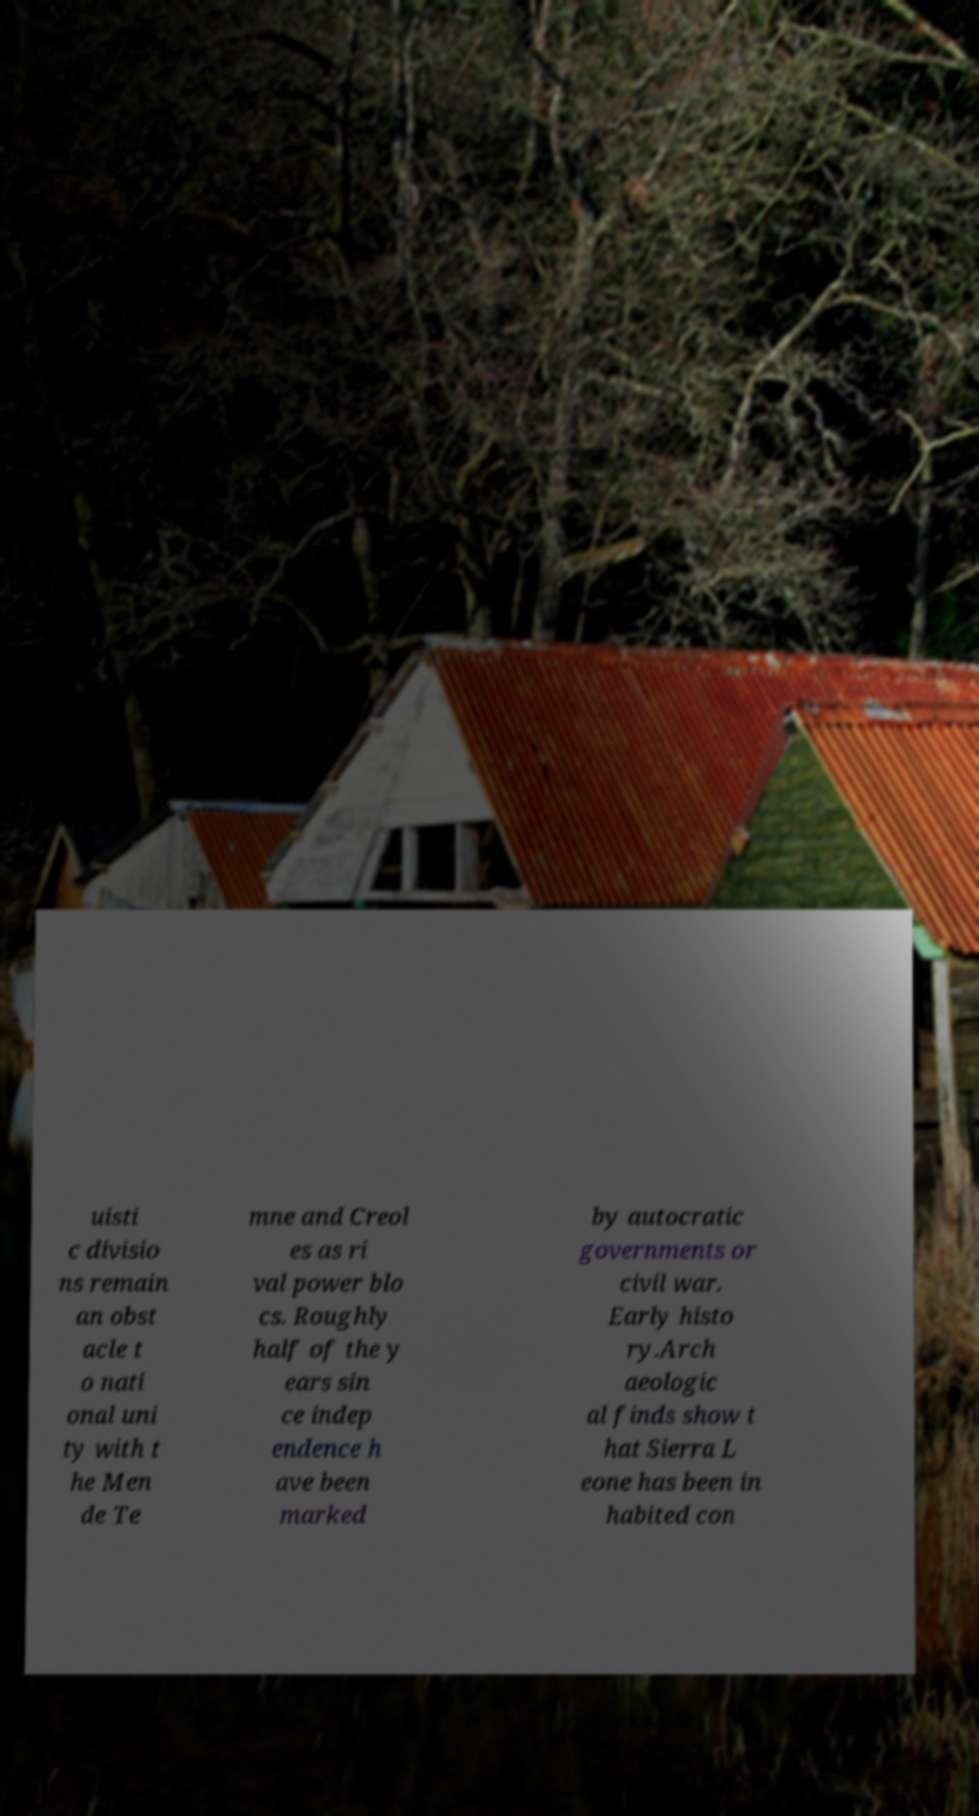For documentation purposes, I need the text within this image transcribed. Could you provide that? uisti c divisio ns remain an obst acle t o nati onal uni ty with t he Men de Te mne and Creol es as ri val power blo cs. Roughly half of the y ears sin ce indep endence h ave been marked by autocratic governments or civil war. Early histo ry.Arch aeologic al finds show t hat Sierra L eone has been in habited con 